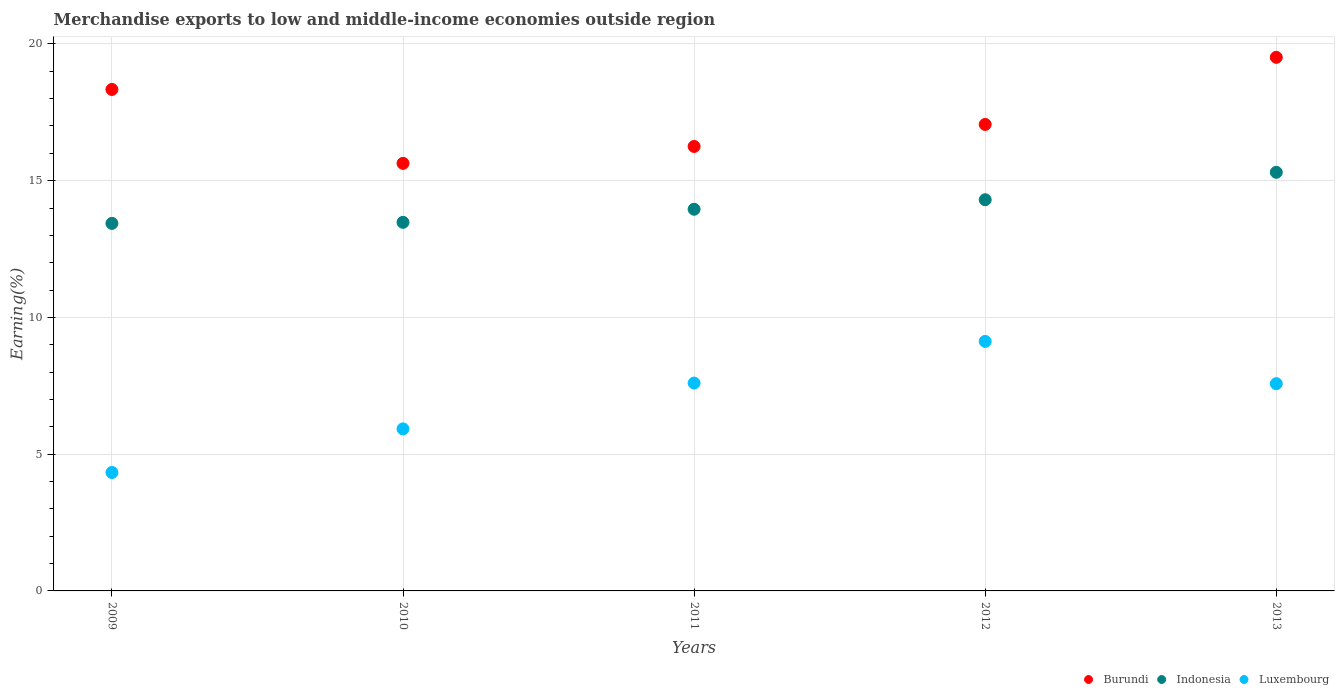What is the percentage of amount earned from merchandise exports in Luxembourg in 2011?
Offer a terse response. 7.6. Across all years, what is the maximum percentage of amount earned from merchandise exports in Luxembourg?
Your answer should be compact. 9.12. Across all years, what is the minimum percentage of amount earned from merchandise exports in Luxembourg?
Your answer should be compact. 4.33. In which year was the percentage of amount earned from merchandise exports in Luxembourg maximum?
Keep it short and to the point. 2012. In which year was the percentage of amount earned from merchandise exports in Indonesia minimum?
Provide a succinct answer. 2009. What is the total percentage of amount earned from merchandise exports in Burundi in the graph?
Provide a short and direct response. 86.79. What is the difference between the percentage of amount earned from merchandise exports in Indonesia in 2012 and that in 2013?
Ensure brevity in your answer.  -1. What is the difference between the percentage of amount earned from merchandise exports in Luxembourg in 2013 and the percentage of amount earned from merchandise exports in Indonesia in 2009?
Keep it short and to the point. -5.86. What is the average percentage of amount earned from merchandise exports in Burundi per year?
Your response must be concise. 17.36. In the year 2010, what is the difference between the percentage of amount earned from merchandise exports in Indonesia and percentage of amount earned from merchandise exports in Luxembourg?
Give a very brief answer. 7.55. What is the ratio of the percentage of amount earned from merchandise exports in Burundi in 2009 to that in 2010?
Offer a terse response. 1.17. Is the percentage of amount earned from merchandise exports in Indonesia in 2009 less than that in 2013?
Provide a succinct answer. Yes. What is the difference between the highest and the second highest percentage of amount earned from merchandise exports in Burundi?
Offer a very short reply. 1.17. What is the difference between the highest and the lowest percentage of amount earned from merchandise exports in Burundi?
Provide a short and direct response. 3.88. In how many years, is the percentage of amount earned from merchandise exports in Indonesia greater than the average percentage of amount earned from merchandise exports in Indonesia taken over all years?
Make the answer very short. 2. Is the percentage of amount earned from merchandise exports in Indonesia strictly greater than the percentage of amount earned from merchandise exports in Burundi over the years?
Make the answer very short. No. How many dotlines are there?
Your answer should be very brief. 3. How many years are there in the graph?
Make the answer very short. 5. What is the difference between two consecutive major ticks on the Y-axis?
Ensure brevity in your answer.  5. Are the values on the major ticks of Y-axis written in scientific E-notation?
Your answer should be compact. No. Where does the legend appear in the graph?
Provide a short and direct response. Bottom right. How are the legend labels stacked?
Keep it short and to the point. Horizontal. What is the title of the graph?
Make the answer very short. Merchandise exports to low and middle-income economies outside region. Does "Macao" appear as one of the legend labels in the graph?
Provide a succinct answer. No. What is the label or title of the X-axis?
Ensure brevity in your answer.  Years. What is the label or title of the Y-axis?
Keep it short and to the point. Earning(%). What is the Earning(%) in Burundi in 2009?
Your answer should be compact. 18.34. What is the Earning(%) in Indonesia in 2009?
Provide a succinct answer. 13.44. What is the Earning(%) of Luxembourg in 2009?
Make the answer very short. 4.33. What is the Earning(%) in Burundi in 2010?
Ensure brevity in your answer.  15.63. What is the Earning(%) of Indonesia in 2010?
Keep it short and to the point. 13.48. What is the Earning(%) of Luxembourg in 2010?
Ensure brevity in your answer.  5.93. What is the Earning(%) of Burundi in 2011?
Give a very brief answer. 16.25. What is the Earning(%) of Indonesia in 2011?
Give a very brief answer. 13.96. What is the Earning(%) of Luxembourg in 2011?
Provide a succinct answer. 7.6. What is the Earning(%) of Burundi in 2012?
Provide a succinct answer. 17.06. What is the Earning(%) in Indonesia in 2012?
Offer a very short reply. 14.3. What is the Earning(%) in Luxembourg in 2012?
Offer a very short reply. 9.12. What is the Earning(%) in Burundi in 2013?
Your response must be concise. 19.51. What is the Earning(%) in Indonesia in 2013?
Provide a succinct answer. 15.31. What is the Earning(%) in Luxembourg in 2013?
Offer a very short reply. 7.58. Across all years, what is the maximum Earning(%) in Burundi?
Offer a very short reply. 19.51. Across all years, what is the maximum Earning(%) in Indonesia?
Your answer should be compact. 15.31. Across all years, what is the maximum Earning(%) of Luxembourg?
Your response must be concise. 9.12. Across all years, what is the minimum Earning(%) in Burundi?
Make the answer very short. 15.63. Across all years, what is the minimum Earning(%) of Indonesia?
Keep it short and to the point. 13.44. Across all years, what is the minimum Earning(%) in Luxembourg?
Provide a succinct answer. 4.33. What is the total Earning(%) of Burundi in the graph?
Give a very brief answer. 86.79. What is the total Earning(%) of Indonesia in the graph?
Provide a succinct answer. 70.48. What is the total Earning(%) in Luxembourg in the graph?
Your response must be concise. 34.56. What is the difference between the Earning(%) of Burundi in 2009 and that in 2010?
Give a very brief answer. 2.7. What is the difference between the Earning(%) in Indonesia in 2009 and that in 2010?
Your response must be concise. -0.04. What is the difference between the Earning(%) of Luxembourg in 2009 and that in 2010?
Offer a very short reply. -1.59. What is the difference between the Earning(%) in Burundi in 2009 and that in 2011?
Offer a terse response. 2.08. What is the difference between the Earning(%) in Indonesia in 2009 and that in 2011?
Provide a succinct answer. -0.52. What is the difference between the Earning(%) in Luxembourg in 2009 and that in 2011?
Offer a very short reply. -3.27. What is the difference between the Earning(%) of Burundi in 2009 and that in 2012?
Offer a terse response. 1.28. What is the difference between the Earning(%) in Indonesia in 2009 and that in 2012?
Your response must be concise. -0.86. What is the difference between the Earning(%) in Luxembourg in 2009 and that in 2012?
Provide a short and direct response. -4.79. What is the difference between the Earning(%) in Burundi in 2009 and that in 2013?
Ensure brevity in your answer.  -1.17. What is the difference between the Earning(%) in Indonesia in 2009 and that in 2013?
Offer a very short reply. -1.87. What is the difference between the Earning(%) in Luxembourg in 2009 and that in 2013?
Make the answer very short. -3.25. What is the difference between the Earning(%) of Burundi in 2010 and that in 2011?
Your response must be concise. -0.62. What is the difference between the Earning(%) in Indonesia in 2010 and that in 2011?
Offer a terse response. -0.48. What is the difference between the Earning(%) of Luxembourg in 2010 and that in 2011?
Ensure brevity in your answer.  -1.68. What is the difference between the Earning(%) of Burundi in 2010 and that in 2012?
Your answer should be compact. -1.42. What is the difference between the Earning(%) of Indonesia in 2010 and that in 2012?
Offer a terse response. -0.83. What is the difference between the Earning(%) in Luxembourg in 2010 and that in 2012?
Give a very brief answer. -3.2. What is the difference between the Earning(%) in Burundi in 2010 and that in 2013?
Provide a succinct answer. -3.88. What is the difference between the Earning(%) of Indonesia in 2010 and that in 2013?
Offer a terse response. -1.83. What is the difference between the Earning(%) of Luxembourg in 2010 and that in 2013?
Make the answer very short. -1.65. What is the difference between the Earning(%) of Burundi in 2011 and that in 2012?
Give a very brief answer. -0.81. What is the difference between the Earning(%) in Indonesia in 2011 and that in 2012?
Ensure brevity in your answer.  -0.35. What is the difference between the Earning(%) in Luxembourg in 2011 and that in 2012?
Give a very brief answer. -1.52. What is the difference between the Earning(%) in Burundi in 2011 and that in 2013?
Keep it short and to the point. -3.26. What is the difference between the Earning(%) of Indonesia in 2011 and that in 2013?
Ensure brevity in your answer.  -1.35. What is the difference between the Earning(%) in Luxembourg in 2011 and that in 2013?
Offer a terse response. 0.02. What is the difference between the Earning(%) of Burundi in 2012 and that in 2013?
Give a very brief answer. -2.45. What is the difference between the Earning(%) of Indonesia in 2012 and that in 2013?
Ensure brevity in your answer.  -1. What is the difference between the Earning(%) in Luxembourg in 2012 and that in 2013?
Your answer should be compact. 1.55. What is the difference between the Earning(%) in Burundi in 2009 and the Earning(%) in Indonesia in 2010?
Offer a terse response. 4.86. What is the difference between the Earning(%) in Burundi in 2009 and the Earning(%) in Luxembourg in 2010?
Give a very brief answer. 12.41. What is the difference between the Earning(%) of Indonesia in 2009 and the Earning(%) of Luxembourg in 2010?
Offer a terse response. 7.51. What is the difference between the Earning(%) of Burundi in 2009 and the Earning(%) of Indonesia in 2011?
Offer a very short reply. 4.38. What is the difference between the Earning(%) of Burundi in 2009 and the Earning(%) of Luxembourg in 2011?
Ensure brevity in your answer.  10.74. What is the difference between the Earning(%) of Indonesia in 2009 and the Earning(%) of Luxembourg in 2011?
Provide a succinct answer. 5.84. What is the difference between the Earning(%) of Burundi in 2009 and the Earning(%) of Indonesia in 2012?
Your answer should be very brief. 4.03. What is the difference between the Earning(%) in Burundi in 2009 and the Earning(%) in Luxembourg in 2012?
Offer a terse response. 9.21. What is the difference between the Earning(%) in Indonesia in 2009 and the Earning(%) in Luxembourg in 2012?
Keep it short and to the point. 4.32. What is the difference between the Earning(%) of Burundi in 2009 and the Earning(%) of Indonesia in 2013?
Provide a succinct answer. 3.03. What is the difference between the Earning(%) of Burundi in 2009 and the Earning(%) of Luxembourg in 2013?
Provide a succinct answer. 10.76. What is the difference between the Earning(%) of Indonesia in 2009 and the Earning(%) of Luxembourg in 2013?
Your response must be concise. 5.86. What is the difference between the Earning(%) in Burundi in 2010 and the Earning(%) in Indonesia in 2011?
Keep it short and to the point. 1.68. What is the difference between the Earning(%) in Burundi in 2010 and the Earning(%) in Luxembourg in 2011?
Offer a terse response. 8.03. What is the difference between the Earning(%) of Indonesia in 2010 and the Earning(%) of Luxembourg in 2011?
Keep it short and to the point. 5.88. What is the difference between the Earning(%) in Burundi in 2010 and the Earning(%) in Indonesia in 2012?
Your response must be concise. 1.33. What is the difference between the Earning(%) in Burundi in 2010 and the Earning(%) in Luxembourg in 2012?
Your answer should be compact. 6.51. What is the difference between the Earning(%) of Indonesia in 2010 and the Earning(%) of Luxembourg in 2012?
Offer a terse response. 4.35. What is the difference between the Earning(%) of Burundi in 2010 and the Earning(%) of Indonesia in 2013?
Your answer should be very brief. 0.33. What is the difference between the Earning(%) in Burundi in 2010 and the Earning(%) in Luxembourg in 2013?
Your answer should be compact. 8.06. What is the difference between the Earning(%) in Indonesia in 2010 and the Earning(%) in Luxembourg in 2013?
Make the answer very short. 5.9. What is the difference between the Earning(%) in Burundi in 2011 and the Earning(%) in Indonesia in 2012?
Give a very brief answer. 1.95. What is the difference between the Earning(%) of Burundi in 2011 and the Earning(%) of Luxembourg in 2012?
Provide a short and direct response. 7.13. What is the difference between the Earning(%) in Indonesia in 2011 and the Earning(%) in Luxembourg in 2012?
Your answer should be compact. 4.83. What is the difference between the Earning(%) in Burundi in 2011 and the Earning(%) in Indonesia in 2013?
Make the answer very short. 0.95. What is the difference between the Earning(%) in Burundi in 2011 and the Earning(%) in Luxembourg in 2013?
Give a very brief answer. 8.67. What is the difference between the Earning(%) in Indonesia in 2011 and the Earning(%) in Luxembourg in 2013?
Keep it short and to the point. 6.38. What is the difference between the Earning(%) of Burundi in 2012 and the Earning(%) of Indonesia in 2013?
Ensure brevity in your answer.  1.75. What is the difference between the Earning(%) of Burundi in 2012 and the Earning(%) of Luxembourg in 2013?
Keep it short and to the point. 9.48. What is the difference between the Earning(%) in Indonesia in 2012 and the Earning(%) in Luxembourg in 2013?
Your answer should be compact. 6.73. What is the average Earning(%) in Burundi per year?
Keep it short and to the point. 17.36. What is the average Earning(%) in Indonesia per year?
Keep it short and to the point. 14.1. What is the average Earning(%) in Luxembourg per year?
Offer a very short reply. 6.91. In the year 2009, what is the difference between the Earning(%) in Burundi and Earning(%) in Indonesia?
Your answer should be compact. 4.9. In the year 2009, what is the difference between the Earning(%) in Burundi and Earning(%) in Luxembourg?
Provide a short and direct response. 14.01. In the year 2009, what is the difference between the Earning(%) of Indonesia and Earning(%) of Luxembourg?
Your answer should be compact. 9.11. In the year 2010, what is the difference between the Earning(%) of Burundi and Earning(%) of Indonesia?
Offer a terse response. 2.16. In the year 2010, what is the difference between the Earning(%) of Burundi and Earning(%) of Luxembourg?
Your response must be concise. 9.71. In the year 2010, what is the difference between the Earning(%) of Indonesia and Earning(%) of Luxembourg?
Ensure brevity in your answer.  7.55. In the year 2011, what is the difference between the Earning(%) of Burundi and Earning(%) of Indonesia?
Provide a succinct answer. 2.3. In the year 2011, what is the difference between the Earning(%) of Burundi and Earning(%) of Luxembourg?
Your answer should be compact. 8.65. In the year 2011, what is the difference between the Earning(%) in Indonesia and Earning(%) in Luxembourg?
Your answer should be compact. 6.36. In the year 2012, what is the difference between the Earning(%) in Burundi and Earning(%) in Indonesia?
Offer a terse response. 2.75. In the year 2012, what is the difference between the Earning(%) of Burundi and Earning(%) of Luxembourg?
Offer a very short reply. 7.93. In the year 2012, what is the difference between the Earning(%) in Indonesia and Earning(%) in Luxembourg?
Your answer should be very brief. 5.18. In the year 2013, what is the difference between the Earning(%) of Burundi and Earning(%) of Indonesia?
Offer a very short reply. 4.2. In the year 2013, what is the difference between the Earning(%) in Burundi and Earning(%) in Luxembourg?
Provide a succinct answer. 11.93. In the year 2013, what is the difference between the Earning(%) in Indonesia and Earning(%) in Luxembourg?
Offer a very short reply. 7.73. What is the ratio of the Earning(%) of Burundi in 2009 to that in 2010?
Make the answer very short. 1.17. What is the ratio of the Earning(%) of Luxembourg in 2009 to that in 2010?
Your answer should be compact. 0.73. What is the ratio of the Earning(%) in Burundi in 2009 to that in 2011?
Keep it short and to the point. 1.13. What is the ratio of the Earning(%) of Indonesia in 2009 to that in 2011?
Provide a short and direct response. 0.96. What is the ratio of the Earning(%) in Luxembourg in 2009 to that in 2011?
Provide a short and direct response. 0.57. What is the ratio of the Earning(%) of Burundi in 2009 to that in 2012?
Offer a terse response. 1.07. What is the ratio of the Earning(%) of Indonesia in 2009 to that in 2012?
Keep it short and to the point. 0.94. What is the ratio of the Earning(%) in Luxembourg in 2009 to that in 2012?
Give a very brief answer. 0.47. What is the ratio of the Earning(%) of Burundi in 2009 to that in 2013?
Provide a succinct answer. 0.94. What is the ratio of the Earning(%) in Indonesia in 2009 to that in 2013?
Provide a succinct answer. 0.88. What is the ratio of the Earning(%) of Luxembourg in 2009 to that in 2013?
Your response must be concise. 0.57. What is the ratio of the Earning(%) in Burundi in 2010 to that in 2011?
Provide a short and direct response. 0.96. What is the ratio of the Earning(%) of Indonesia in 2010 to that in 2011?
Make the answer very short. 0.97. What is the ratio of the Earning(%) in Luxembourg in 2010 to that in 2011?
Your answer should be compact. 0.78. What is the ratio of the Earning(%) in Burundi in 2010 to that in 2012?
Offer a very short reply. 0.92. What is the ratio of the Earning(%) in Indonesia in 2010 to that in 2012?
Your response must be concise. 0.94. What is the ratio of the Earning(%) of Luxembourg in 2010 to that in 2012?
Offer a terse response. 0.65. What is the ratio of the Earning(%) of Burundi in 2010 to that in 2013?
Offer a very short reply. 0.8. What is the ratio of the Earning(%) of Indonesia in 2010 to that in 2013?
Provide a short and direct response. 0.88. What is the ratio of the Earning(%) in Luxembourg in 2010 to that in 2013?
Provide a short and direct response. 0.78. What is the ratio of the Earning(%) of Burundi in 2011 to that in 2012?
Your answer should be compact. 0.95. What is the ratio of the Earning(%) in Indonesia in 2011 to that in 2012?
Provide a short and direct response. 0.98. What is the ratio of the Earning(%) of Luxembourg in 2011 to that in 2012?
Offer a very short reply. 0.83. What is the ratio of the Earning(%) in Burundi in 2011 to that in 2013?
Give a very brief answer. 0.83. What is the ratio of the Earning(%) of Indonesia in 2011 to that in 2013?
Keep it short and to the point. 0.91. What is the ratio of the Earning(%) of Luxembourg in 2011 to that in 2013?
Give a very brief answer. 1. What is the ratio of the Earning(%) in Burundi in 2012 to that in 2013?
Keep it short and to the point. 0.87. What is the ratio of the Earning(%) of Indonesia in 2012 to that in 2013?
Your response must be concise. 0.93. What is the ratio of the Earning(%) of Luxembourg in 2012 to that in 2013?
Provide a succinct answer. 1.2. What is the difference between the highest and the second highest Earning(%) of Burundi?
Provide a succinct answer. 1.17. What is the difference between the highest and the second highest Earning(%) in Indonesia?
Your response must be concise. 1. What is the difference between the highest and the second highest Earning(%) of Luxembourg?
Provide a short and direct response. 1.52. What is the difference between the highest and the lowest Earning(%) of Burundi?
Give a very brief answer. 3.88. What is the difference between the highest and the lowest Earning(%) of Indonesia?
Give a very brief answer. 1.87. What is the difference between the highest and the lowest Earning(%) of Luxembourg?
Provide a succinct answer. 4.79. 